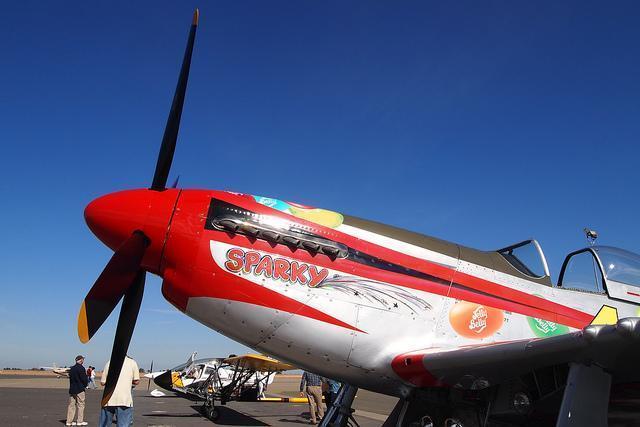How many airplanes are in the photo?
Give a very brief answer. 2. How many motorcycles are parked off the street?
Give a very brief answer. 0. 